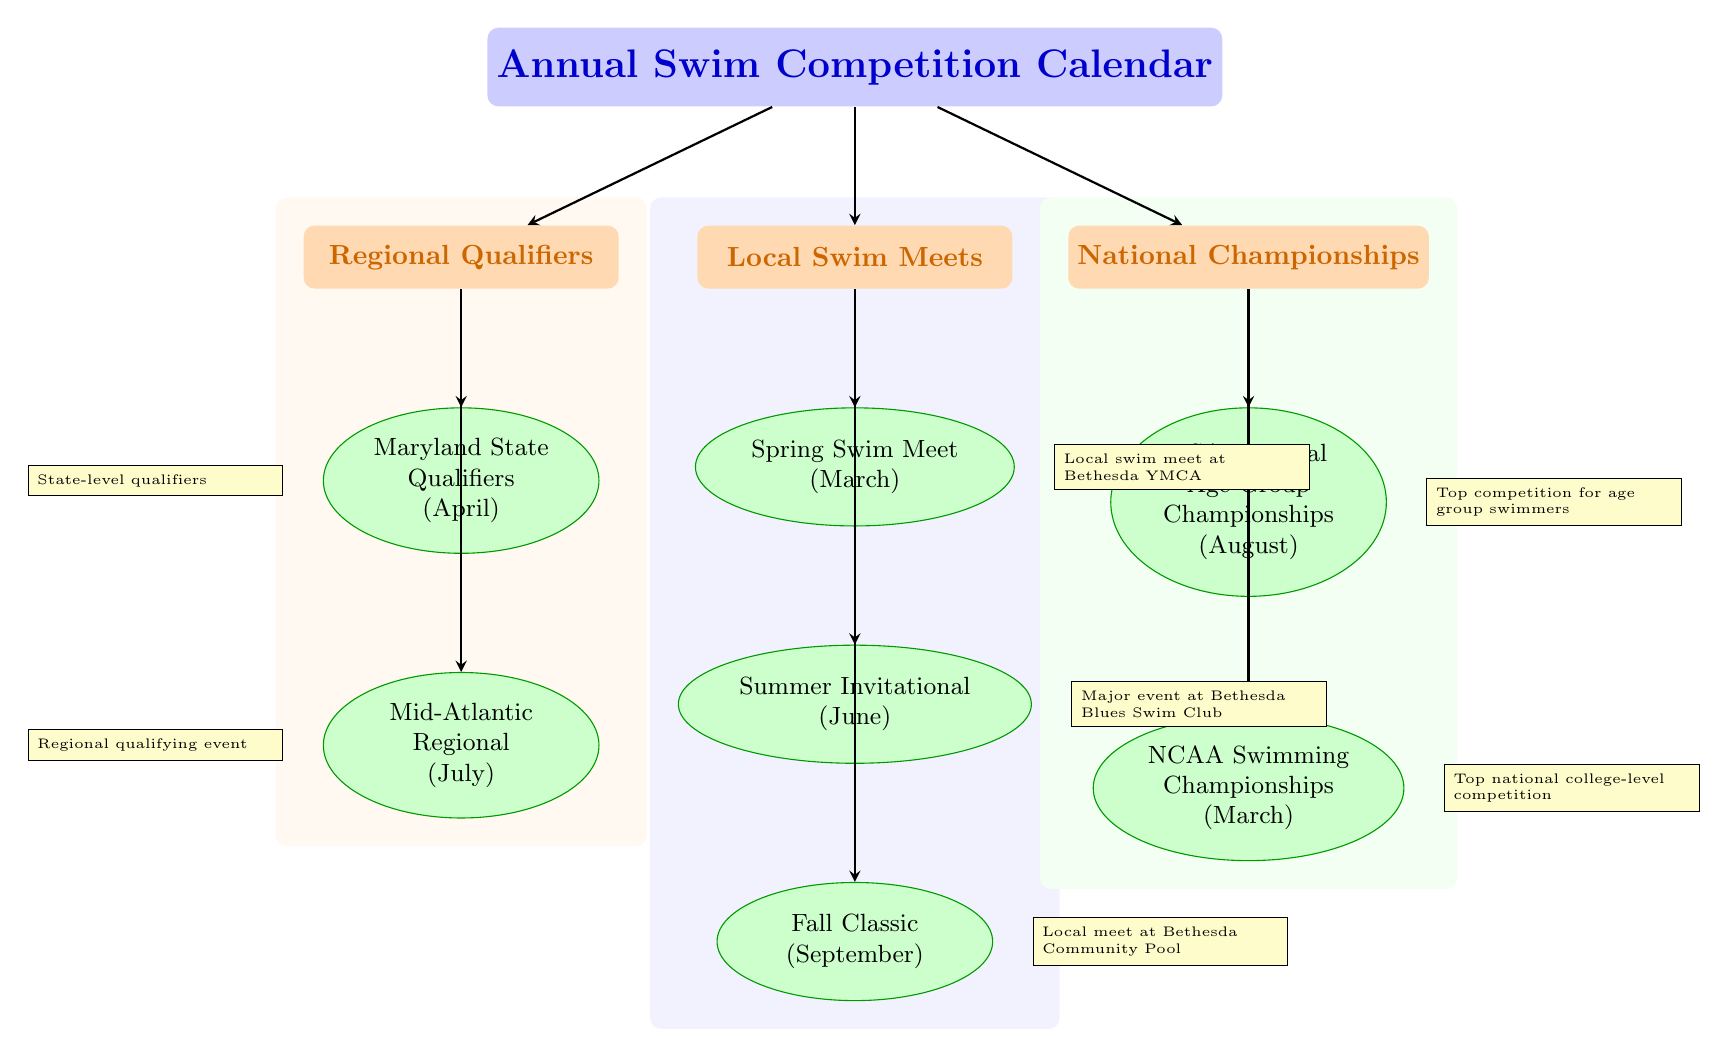What is the first local swim meet listed in the diagram? The diagram lists the local swim meets under the "Local Swim Meets" category, with the first event being labeled as "Spring Swim Meet" in March.
Answer: Spring Swim Meet How many regional qualifiers are shown in the diagram? There are two events listed under the "Regional Qualifiers" category, specifically "Maryland State Qualifiers" in April and "Mid-Atlantic Regional" in July.
Answer: 2 What event takes place in August? The only event listed in August is the "USA National Age Group Championships," which is part of the "National Championships" category in the diagram.
Answer: USA National Age Group Championships Which local meet occurs in June? The diagram identifies "Summer Invitational" as the event taking place in June, which falls under the "Local Swim Meets" category.
Answer: Summer Invitational What color represents the National Championships category? In the diagram, the "National Championships" category is shown in green, as indicated by the shading of that section.
Answer: Green What are the two key qualifiers before the regional qualifiers? The two key events preceding regional qualifiers, according to the diagram, are the "Maryland State Qualifiers" in April and the "Mid-Atlantic Regional" in July.
Answer: Maryland State Qualifiers, Mid-Atlantic Regional Which local meet has a specific location mentioned in its note? The "Fall Classic" has a note mentioning it occurs at the "Bethesda Community Pool," indicating the specific location for that local meet.
Answer: Fall Classic What is the relationship between "NCAA Swimming Championships" and "National Championships"? The "NCAA Swimming Championships" is one of the events listed under the "National Championships" category in the diagram, indicating it is a specific type of national competition.
Answer: Part of National Championships 